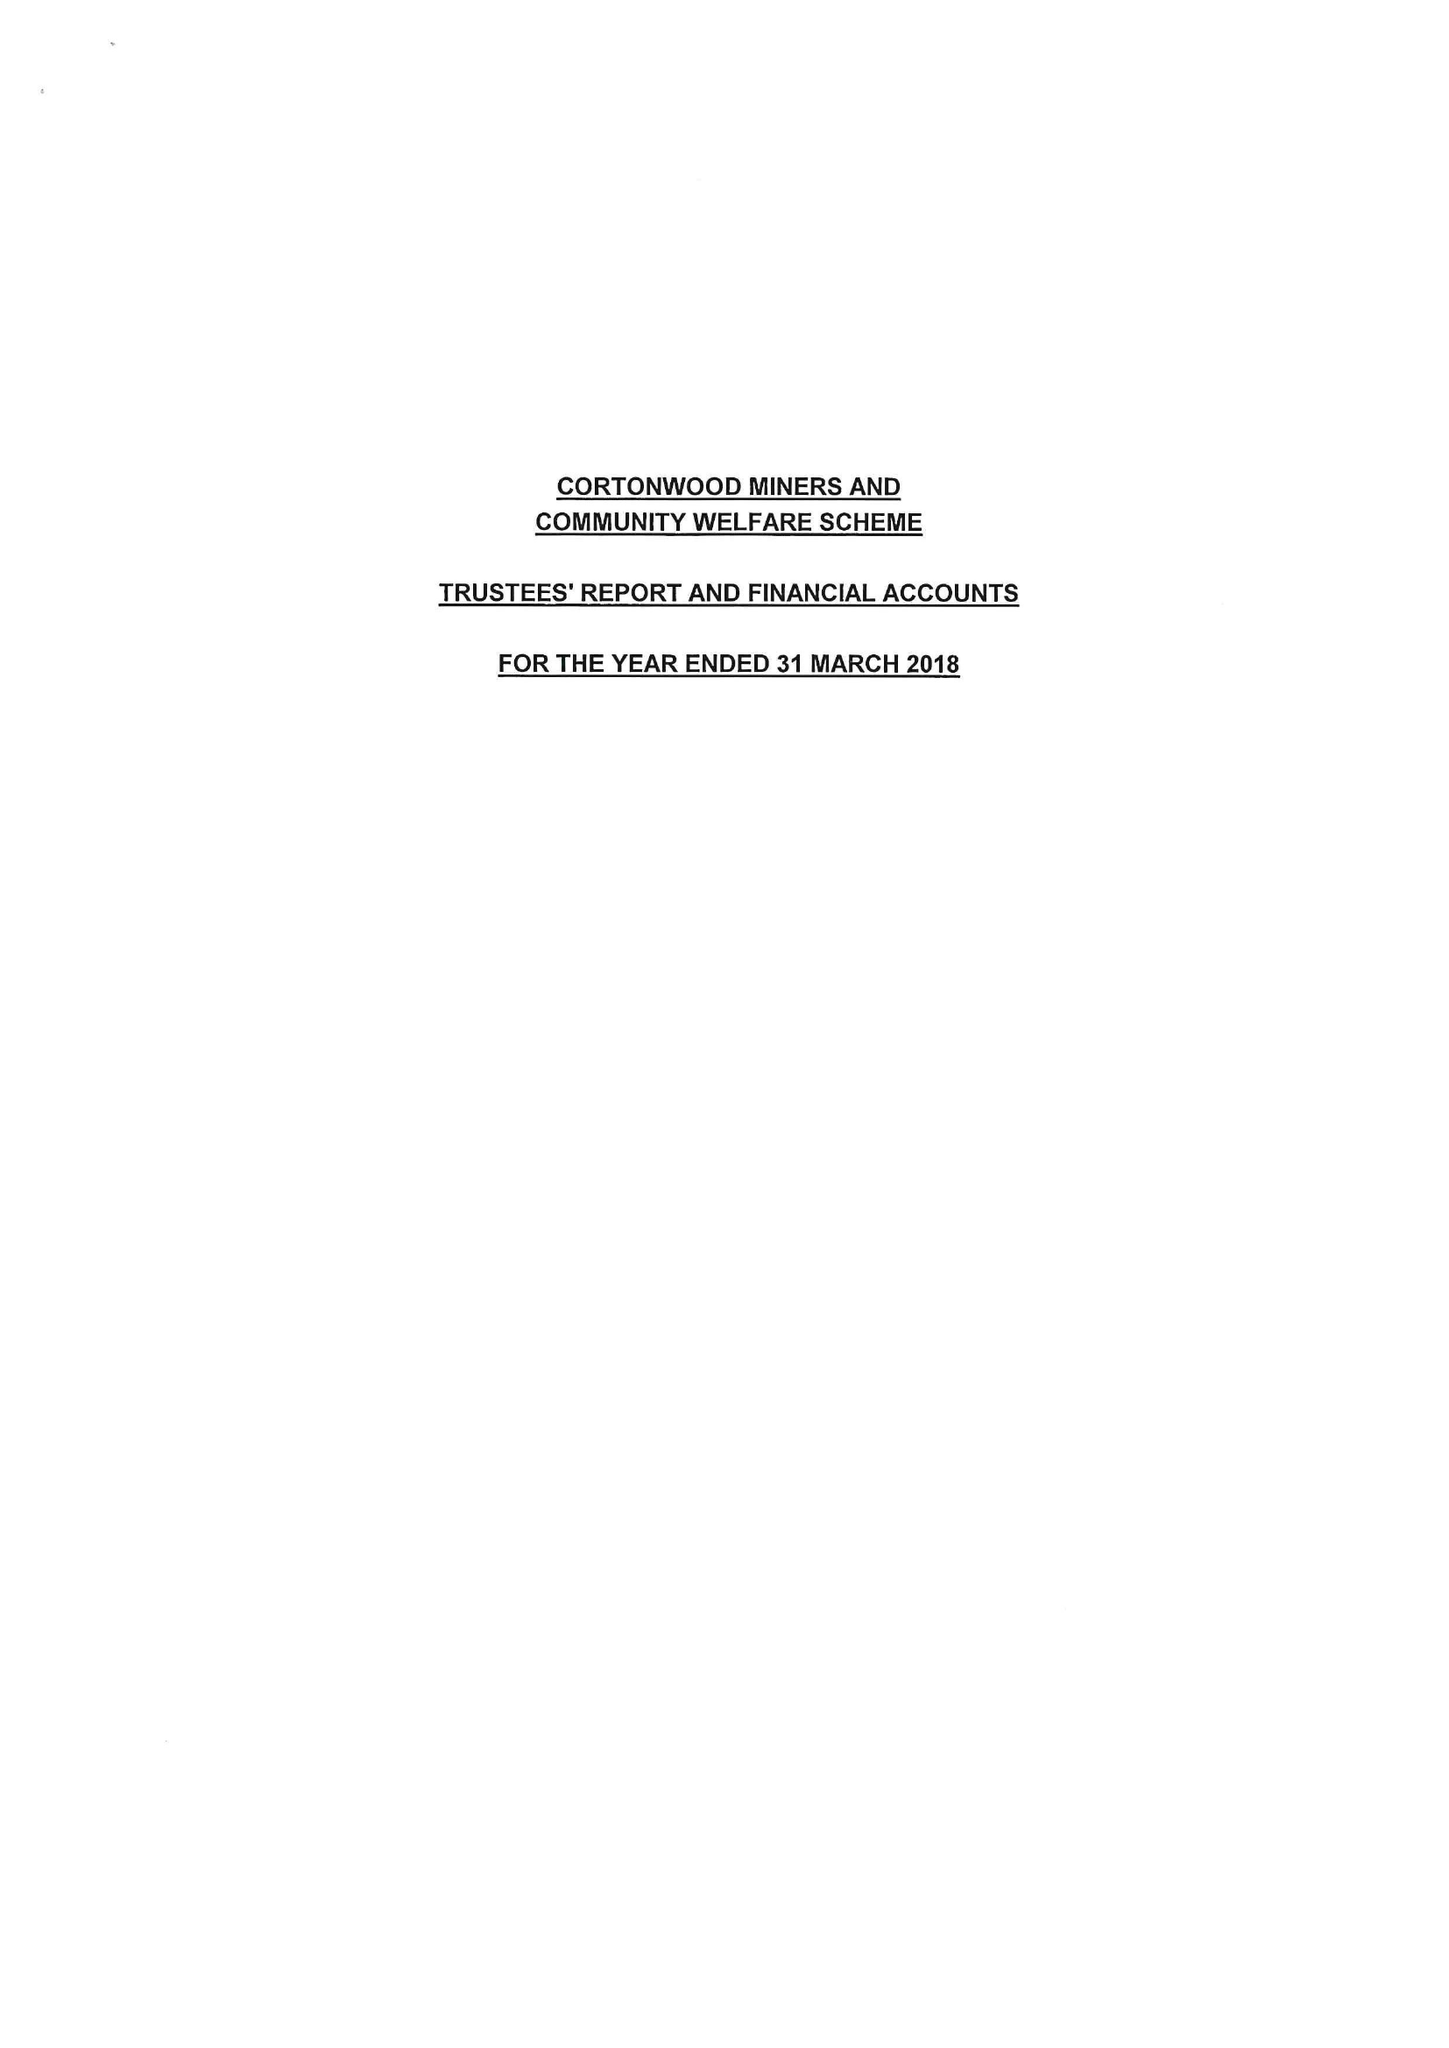What is the value for the income_annually_in_british_pounds?
Answer the question using a single word or phrase. 49780.00 